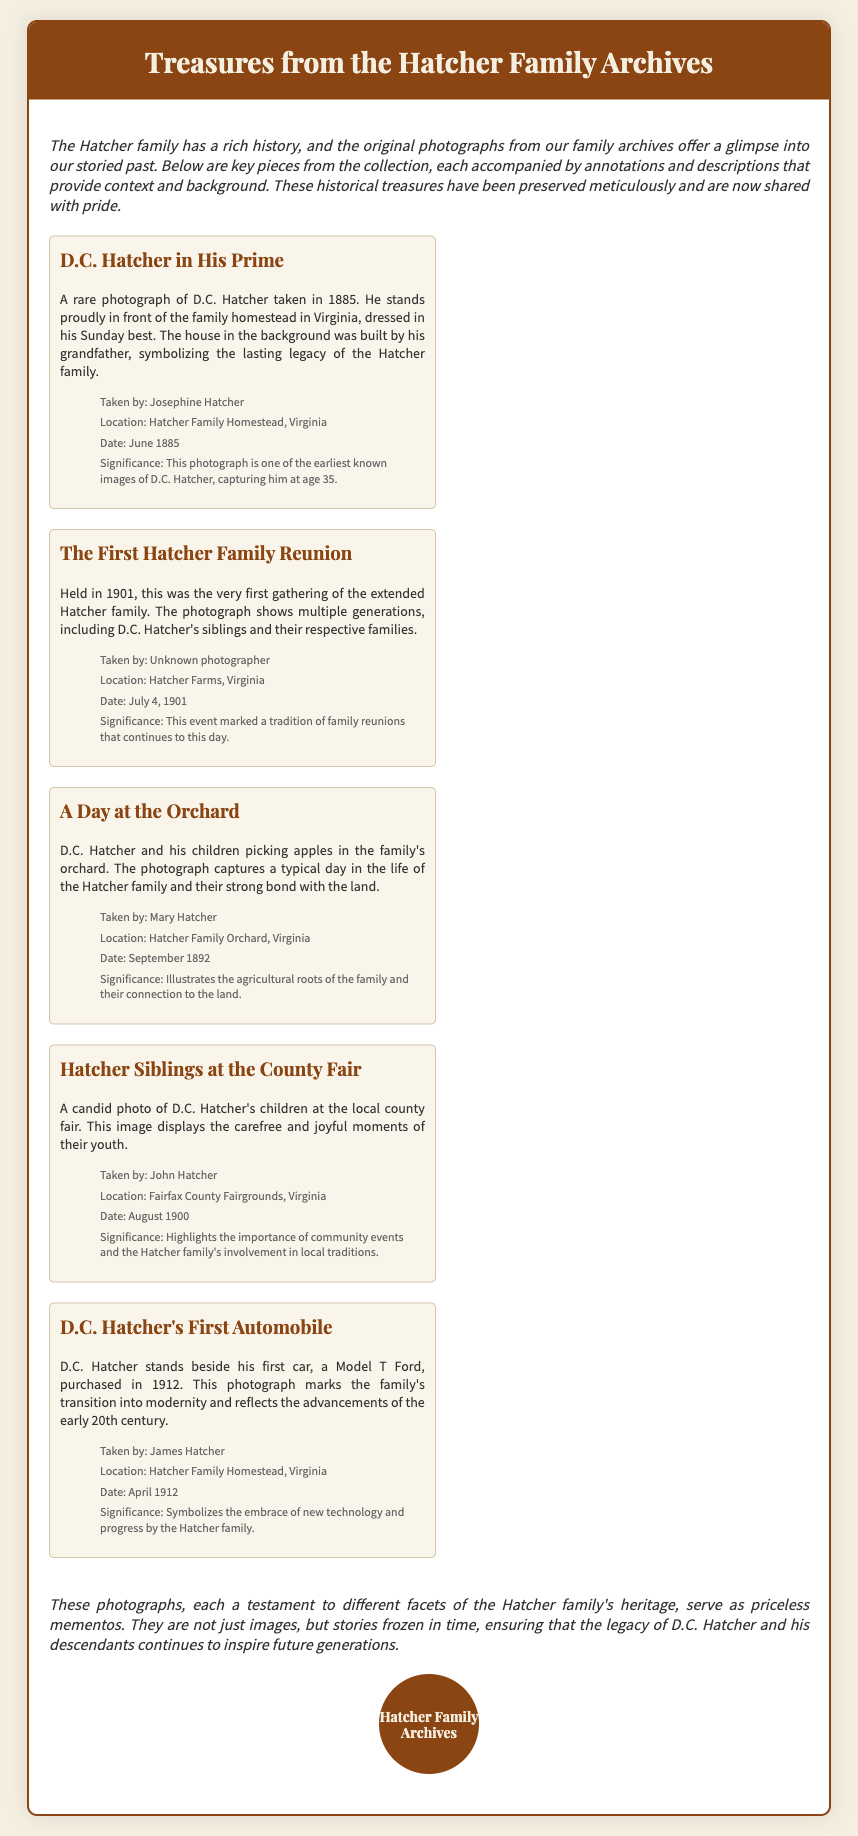What year was the photograph of D.C. Hatcher taken? The photograph is dated June 1885, capturing a moment of D.C. Hatcher at the age of 35.
Answer: 1885 Who took the photograph of the first Hatcher family reunion? The first family reunion photograph was taken by an unknown photographer.
Answer: Unknown photographer What location is featured in the photograph "A Day at the Orchard"? The photograph captures D.C. Hatcher and his children at Hatcher Family Orchard in Virginia.
Answer: Hatcher Family Orchard, Virginia What significant event is marked by the first Hatcher family reunion? The photograph signifies the beginning of a tradition for family reunions that remains alive today.
Answer: Tradition of family reunions In what year was D.C. Hatcher's first automobile purchased? The document states that D.C. Hatcher's first automobile, a Model T Ford, was purchased in April 1912.
Answer: April 1912 What is the primary focus of the photographs from the Hatcher family archives? The photographs are focused on showcasing the rich history and heritage of the Hatcher family.
Answer: Rich history and heritage Which family member is featured in multiple photographs? D.C. Hatcher appears prominently in several photographs, showcasing various aspects of his life.
Answer: D.C. Hatcher What type of document is this based on the provided content? This document is presented as an envelope sharing historical photographs and context about the Hatcher family.
Answer: Envelope of historical photographs 